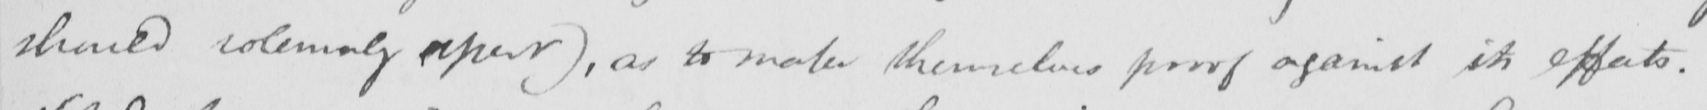Please transcribe the handwritten text in this image. should solemnly assert )  , as to make themselves proof against its effects . 